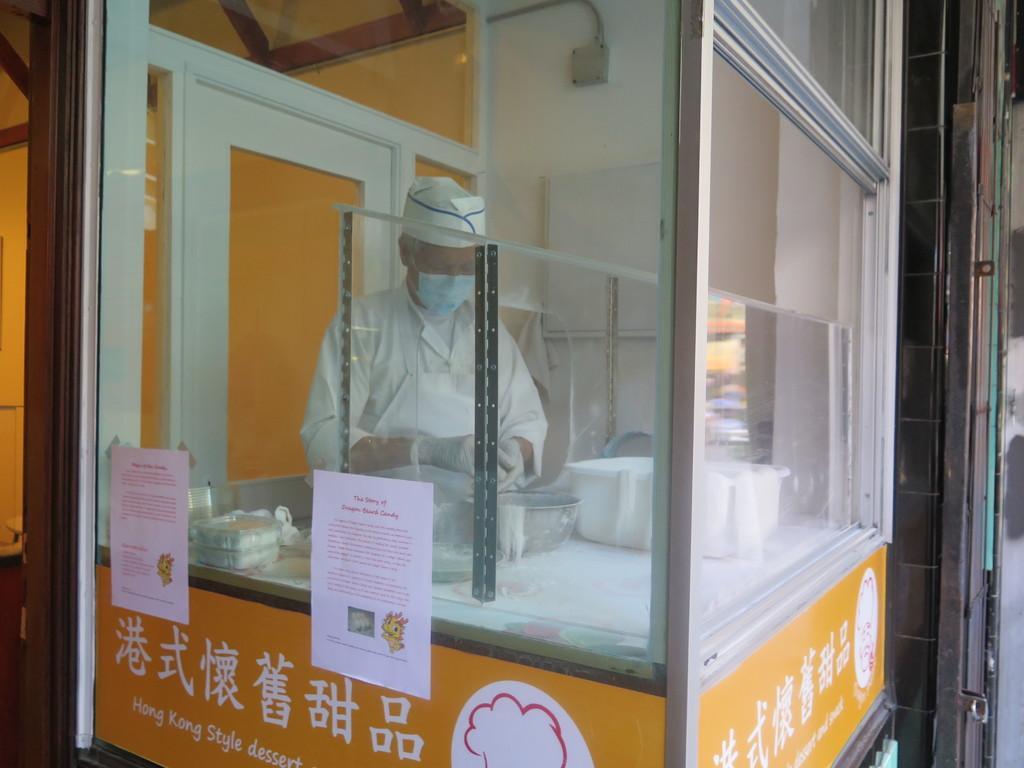Please provide a concise description of this image. In the image we can see there is man standing and he is wearing mask on his mouth. There is a bowl kept on the table and there are papers pasted on the glass. 